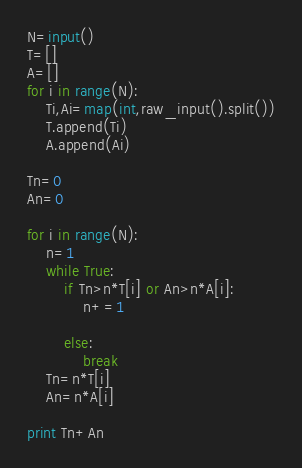<code> <loc_0><loc_0><loc_500><loc_500><_Python_>N=input()
T=[]
A=[]
for i in range(N):
    Ti,Ai=map(int,raw_input().split())
    T.append(Ti)
    A.append(Ai)

Tn=0 
An=0

for i in range(N):
    n=1
    while True:
        if Tn>n*T[i] or An>n*A[i]:
            n+=1

        else:
            break
    Tn=n*T[i]
    An=n*A[i]

print Tn+An
</code> 